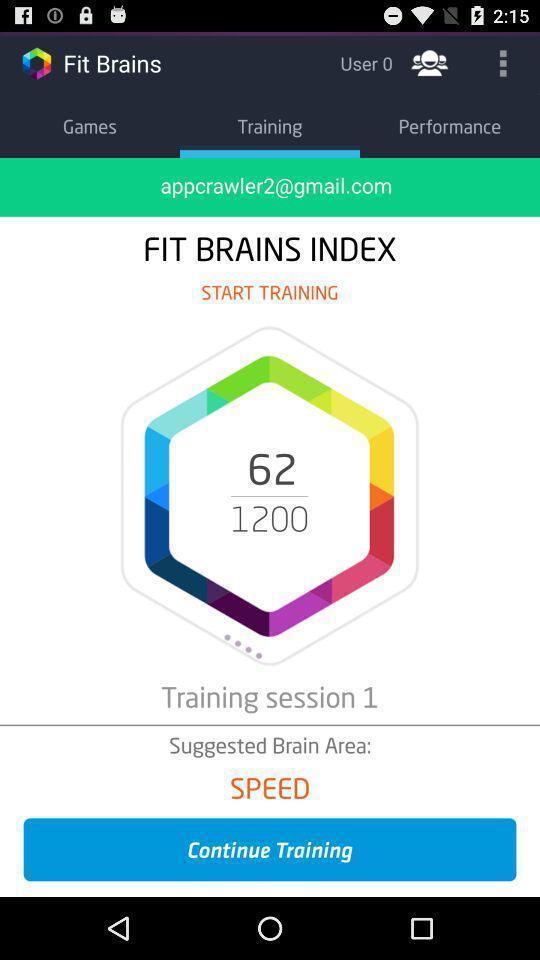What details can you identify in this image? Page with training sessions in a training app. 